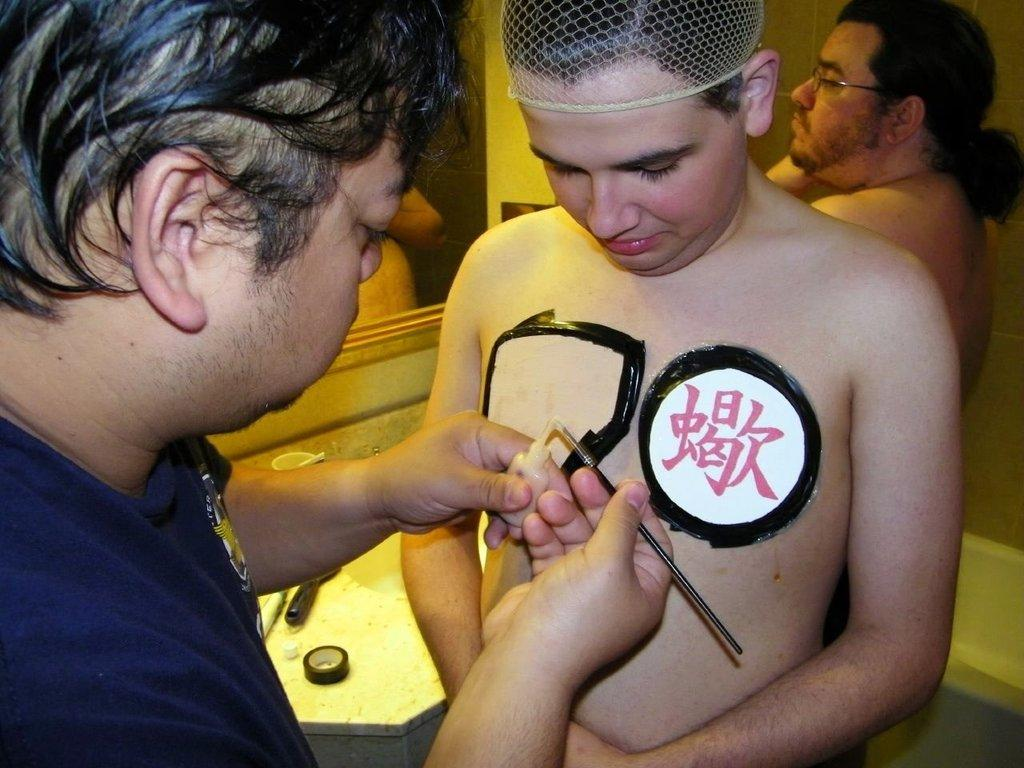How many people are on the left side of the image? There are three persons on the left side of the image. What is one of the persons holding? One of the persons is holding a small bottle. What object can be used for personal grooming or reflection? There is a mirror in the image. What piece of furniture is present in the image? There is a table in the image. What type of ornament is hanging from the ceiling in the image? There is no ornament hanging from the ceiling in the image. What is the desire of the person holding the small bottle in the image? We cannot determine the desires of the person holding the small bottle from the image alone. 